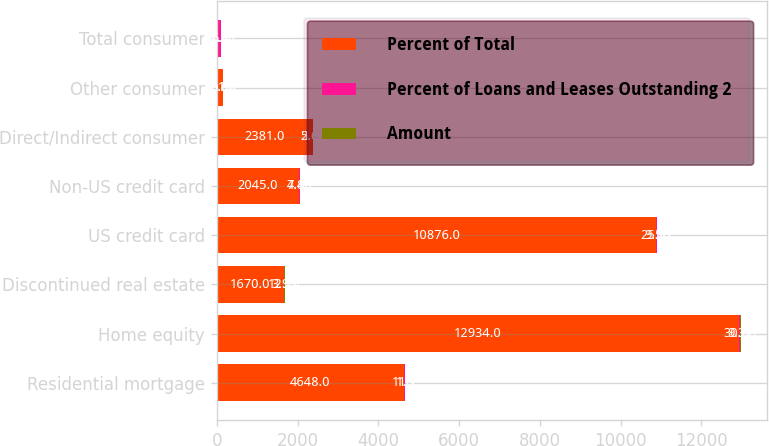Convert chart. <chart><loc_0><loc_0><loc_500><loc_500><stacked_bar_chart><ecel><fcel>Residential mortgage<fcel>Home equity<fcel>Discontinued real estate<fcel>US credit card<fcel>Non-US credit card<fcel>Direct/Indirect consumer<fcel>Other consumer<fcel>Total consumer<nl><fcel>Percent of Total<fcel>4648<fcel>12934<fcel>1670<fcel>10876<fcel>2045<fcel>2381<fcel>161<fcel>11.1<nl><fcel>Percent of Loans and Leases Outstanding 2<fcel>11.1<fcel>30.88<fcel>3.99<fcel>25.97<fcel>4.88<fcel>5.68<fcel>0.38<fcel>82.88<nl><fcel>Amount<fcel>1.8<fcel>9.37<fcel>12.74<fcel>9.56<fcel>7.45<fcel>2.64<fcel>5.67<fcel>5.4<nl></chart> 